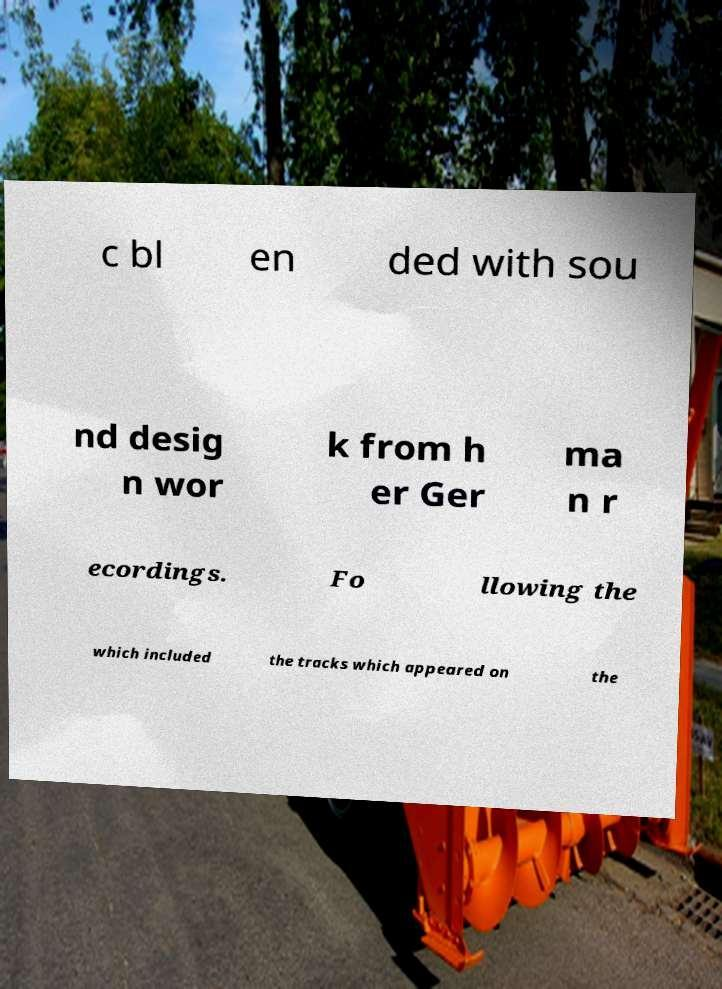Can you accurately transcribe the text from the provided image for me? c bl en ded with sou nd desig n wor k from h er Ger ma n r ecordings. Fo llowing the which included the tracks which appeared on the 